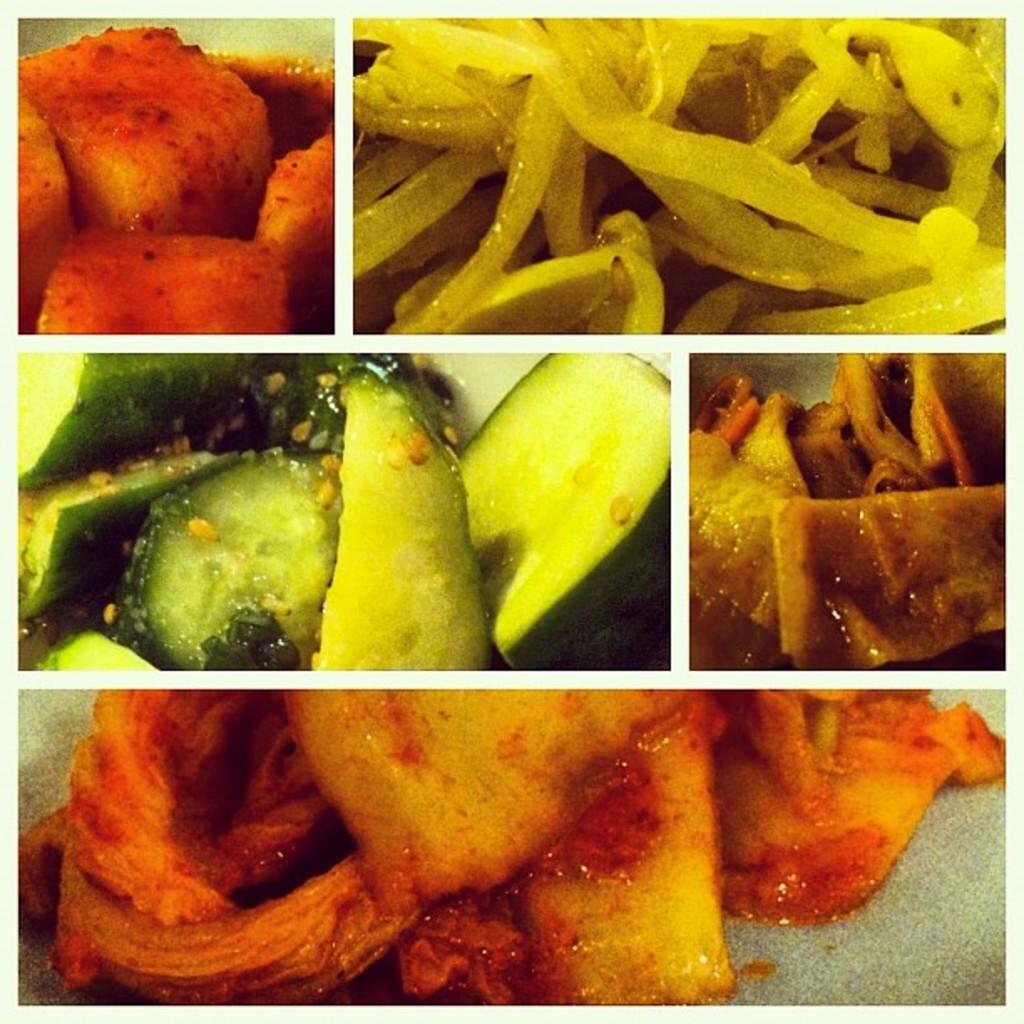Please provide a concise description of this image. This picture describes about college of few images, in this we can find food. 